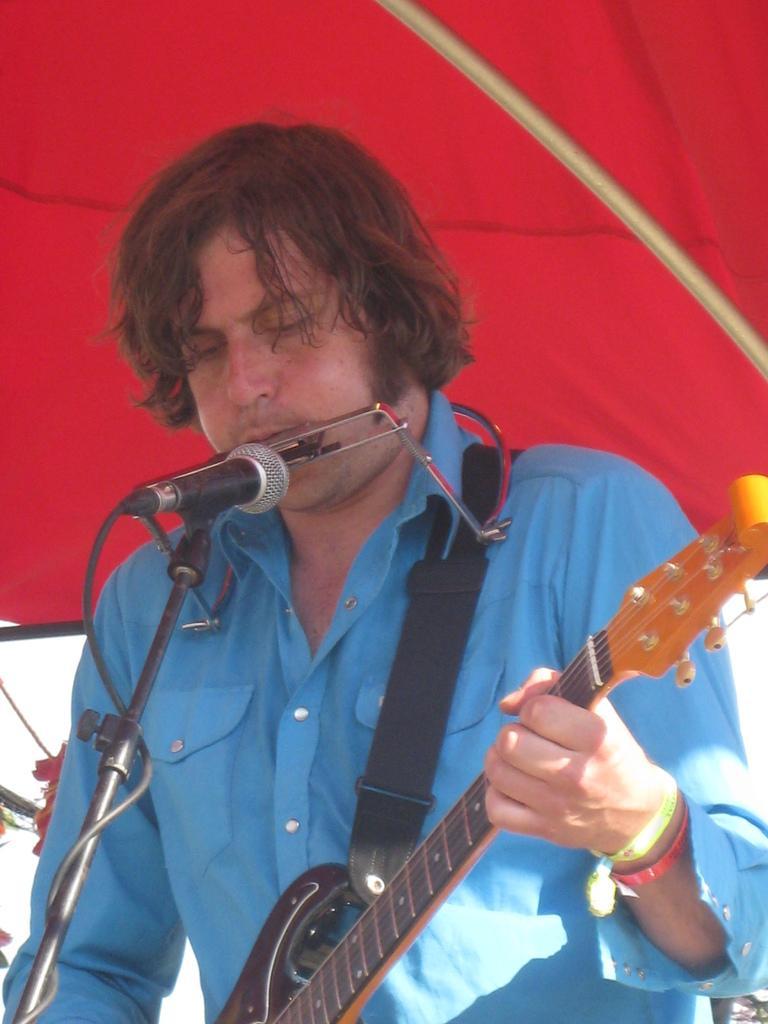Can you describe this image briefly? There is man in blue shirt singing in microphone and playing guitar. 